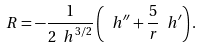Convert formula to latex. <formula><loc_0><loc_0><loc_500><loc_500>R = - \frac { 1 } { 2 { \ h } ^ { 3 / 2 } } \left ( { \ h } ^ { \prime \prime } + \frac { 5 } { r } { \ h } ^ { \prime } \right ) .</formula> 